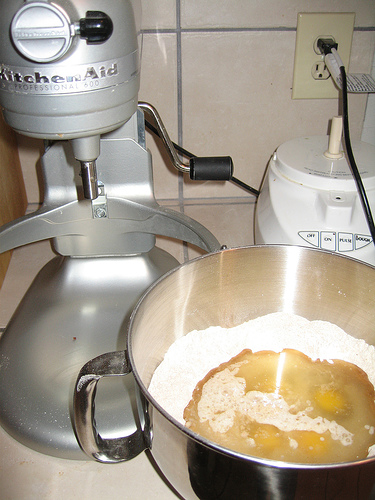<image>
Is the bowl to the left of the mixer? No. The bowl is not to the left of the mixer. From this viewpoint, they have a different horizontal relationship. 